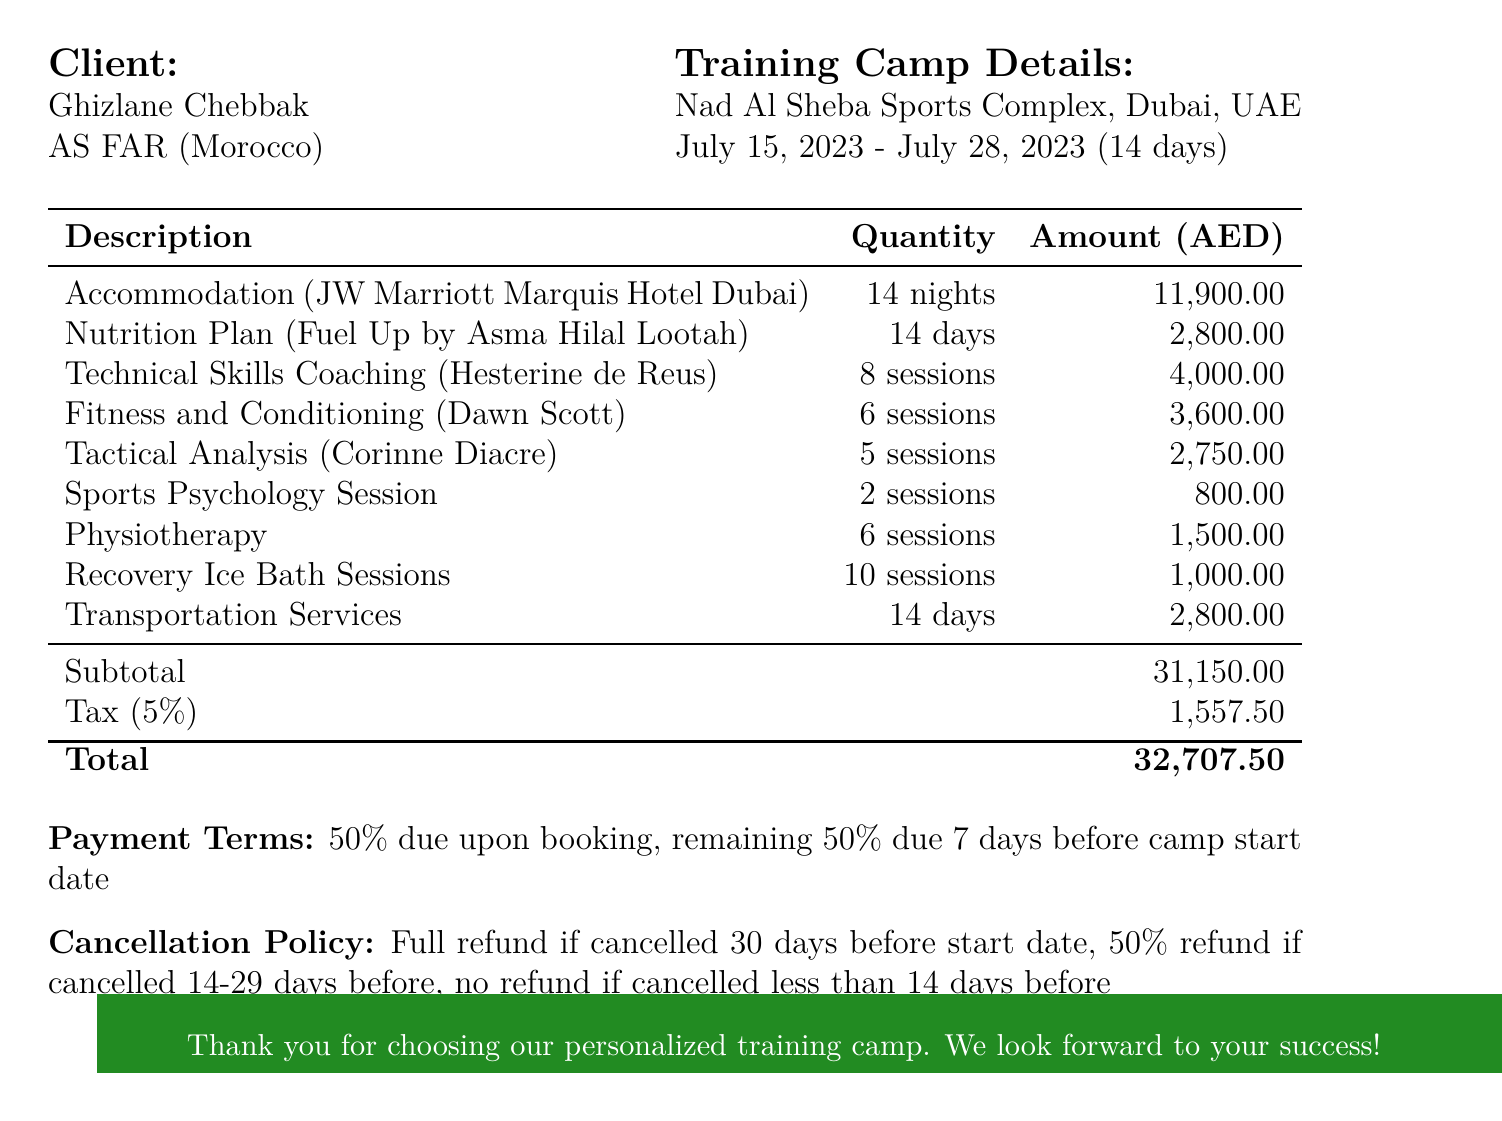What is the invoice number? The invoice number is specified at the top of the document for reference.
Answer: INV-2023-0547 What is the total accommodation cost? The total accommodation cost is calculated based on the nights stayed and cost per night.
Answer: 11900 Who is the first coach listed? The first coach listed is for technical skills coaching and their name is mentioned in the specialized coaching sessions section.
Answer: Hesterine de Reus What is the total cost for nutrition? The total cost for nutrition is derived from the cost per day multiplied by the total days.
Answer: 2800 What percentage is the tax applied to the subtotal? The document explicitly states the tax percentage applied to the subtotal amount.
Answer: 5% What is the duration of the training camp? The duration is clearly stated in the training camp details section of the invoice.
Answer: 14 days What is the cancellation policy for less than 14 days? The cancellation policy outlines the refund options based on the cancellation period.
Answer: No refund What type of room is provided at the hotel? The type of room for accommodation is detailed next to the hotel name.
Answer: Deluxe King Room What is the provider for the transportation services? The provider for transportation services is mentioned in the related section of the invoice.
Answer: Arabian Adventures 